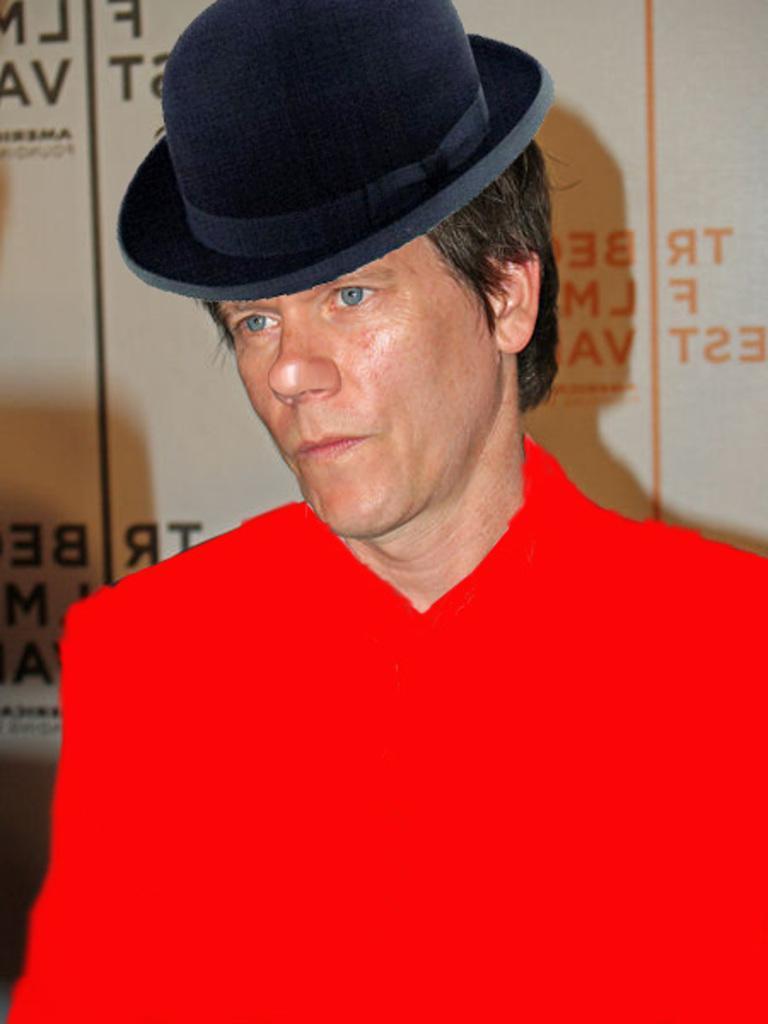Describe this image in one or two sentences. In this image I can see the person wearing the red color dress and hat. In the background I can see something is written. 